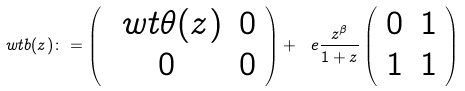<formula> <loc_0><loc_0><loc_500><loc_500>\ w t b ( z ) \colon = \left ( \begin{array} { c c } \ w t \theta ( z ) & 0 \\ 0 & 0 \end{array} \right ) + \ e \frac { z ^ { \beta } } { 1 + z } \left ( \begin{array} { c c } 0 & 1 \\ 1 & 1 \end{array} \right )</formula> 